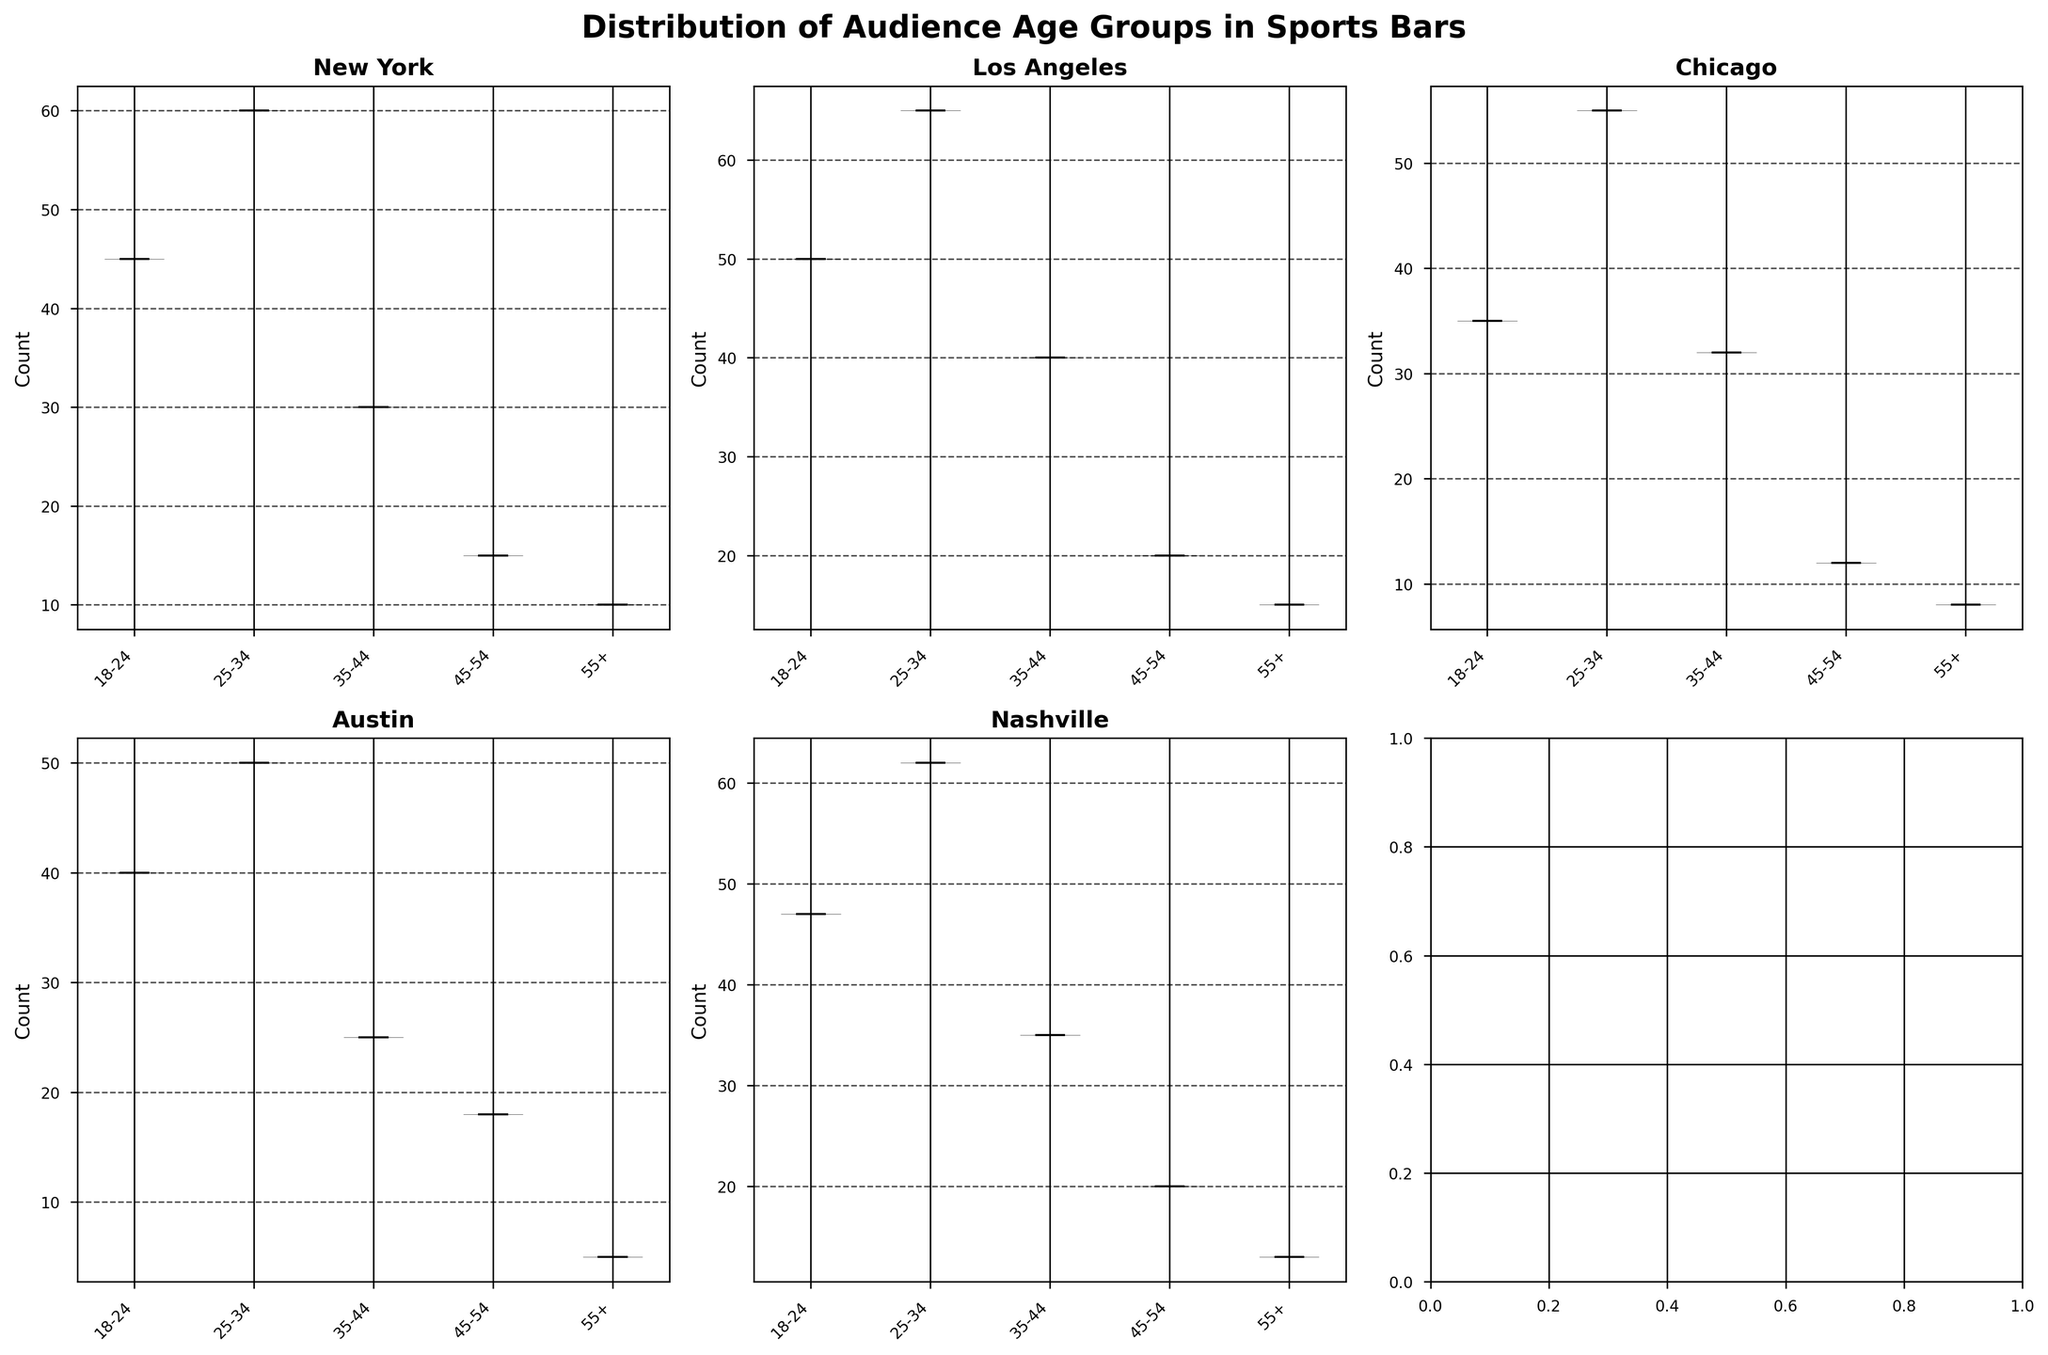What's the overall title of the figure? The title usually appears at the top of the figure and provides a summary of what the figure is about.
Answer: Distribution of Audience Age Groups in Sports Bars How many locations are displayed in the figure? Each subplot corresponds to one location, and they are distributed in a 2x3 grid. By counting the unique titles within the grid, we can determine the number of locations.
Answer: 5 Which location has the highest number of attendees in the 25-34 age group? We observe the median line in the violin plots for the 25-34 age group across all locations and find the plot with the highest median line.
Answer: Los Angeles In which location does the 55+ age group have the least attendees? By analyzing the violin plots, we compare the median lines of the 55+ age group across all locations to find the one with the lowest median value.
Answer: Austin What is the shape feature that distinguishes violin charts? Violin charts have a distinctive shape, representing the distribution and frequency of data points, often resembling a violin. Both ends of the 'violin' show the density of the data points.
Answer: Violin shape Compare and determine which location has a higher median count in the 18-24 age group: New York or Nashville? By comparing the median lines within the 18-24 age group violin plots for New York and Nashville, we can identify which has a higher median count.
Answer: Nashville Which age group is the most attended in Chicago? We need to look at the violin plot for Chicago and determine which age group has the highest median value, indicating the most attendees.
Answer: 25-34 How does the distribution of the 35-44 age group attendees in Austin compare to that in Los Angeles? We compare the width and shape of the violin plots for the 35-44 age group in Austin and Los Angeles, focusing on the median and spread of data points.
Answer: Los Angeles has a wider distribution Which location has the widest spread in the 45-54 age group? The spread of the data is indicated by the width of the violin plot. By comparing the width of the 45-54 age group plots across all locations, we identify the one with the widest spread.
Answer: Los Angeles Identify if any age group has a uniform distribution across locations. A uniform distribution would be indicated by very similar shapes and median lines in the violin plots across all locations for a specific age group. A detailed comparison needs to be done.
Answer: None 